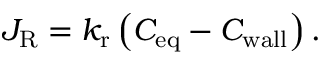<formula> <loc_0><loc_0><loc_500><loc_500>J _ { R } = k _ { r } \left ( C _ { e q } - C _ { w a l l } \right ) .</formula> 